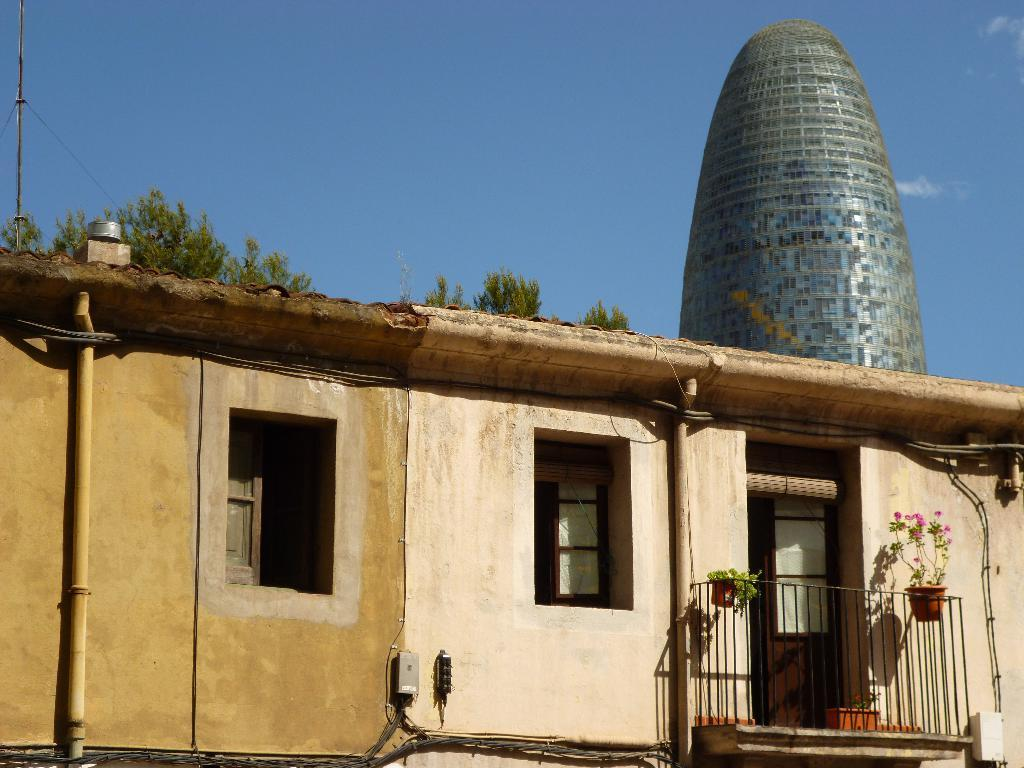What structure is present on the exterior of the building in the image? There is a balcony in the image. What can be found on the balcony? There are two plants on the balcony. How many windows are visible in the image? There are two windows in the image. What type of hen can be seen sitting on the wire in the image? There is no hen or wire present in the image; it only features a balcony, plants, and windows. 